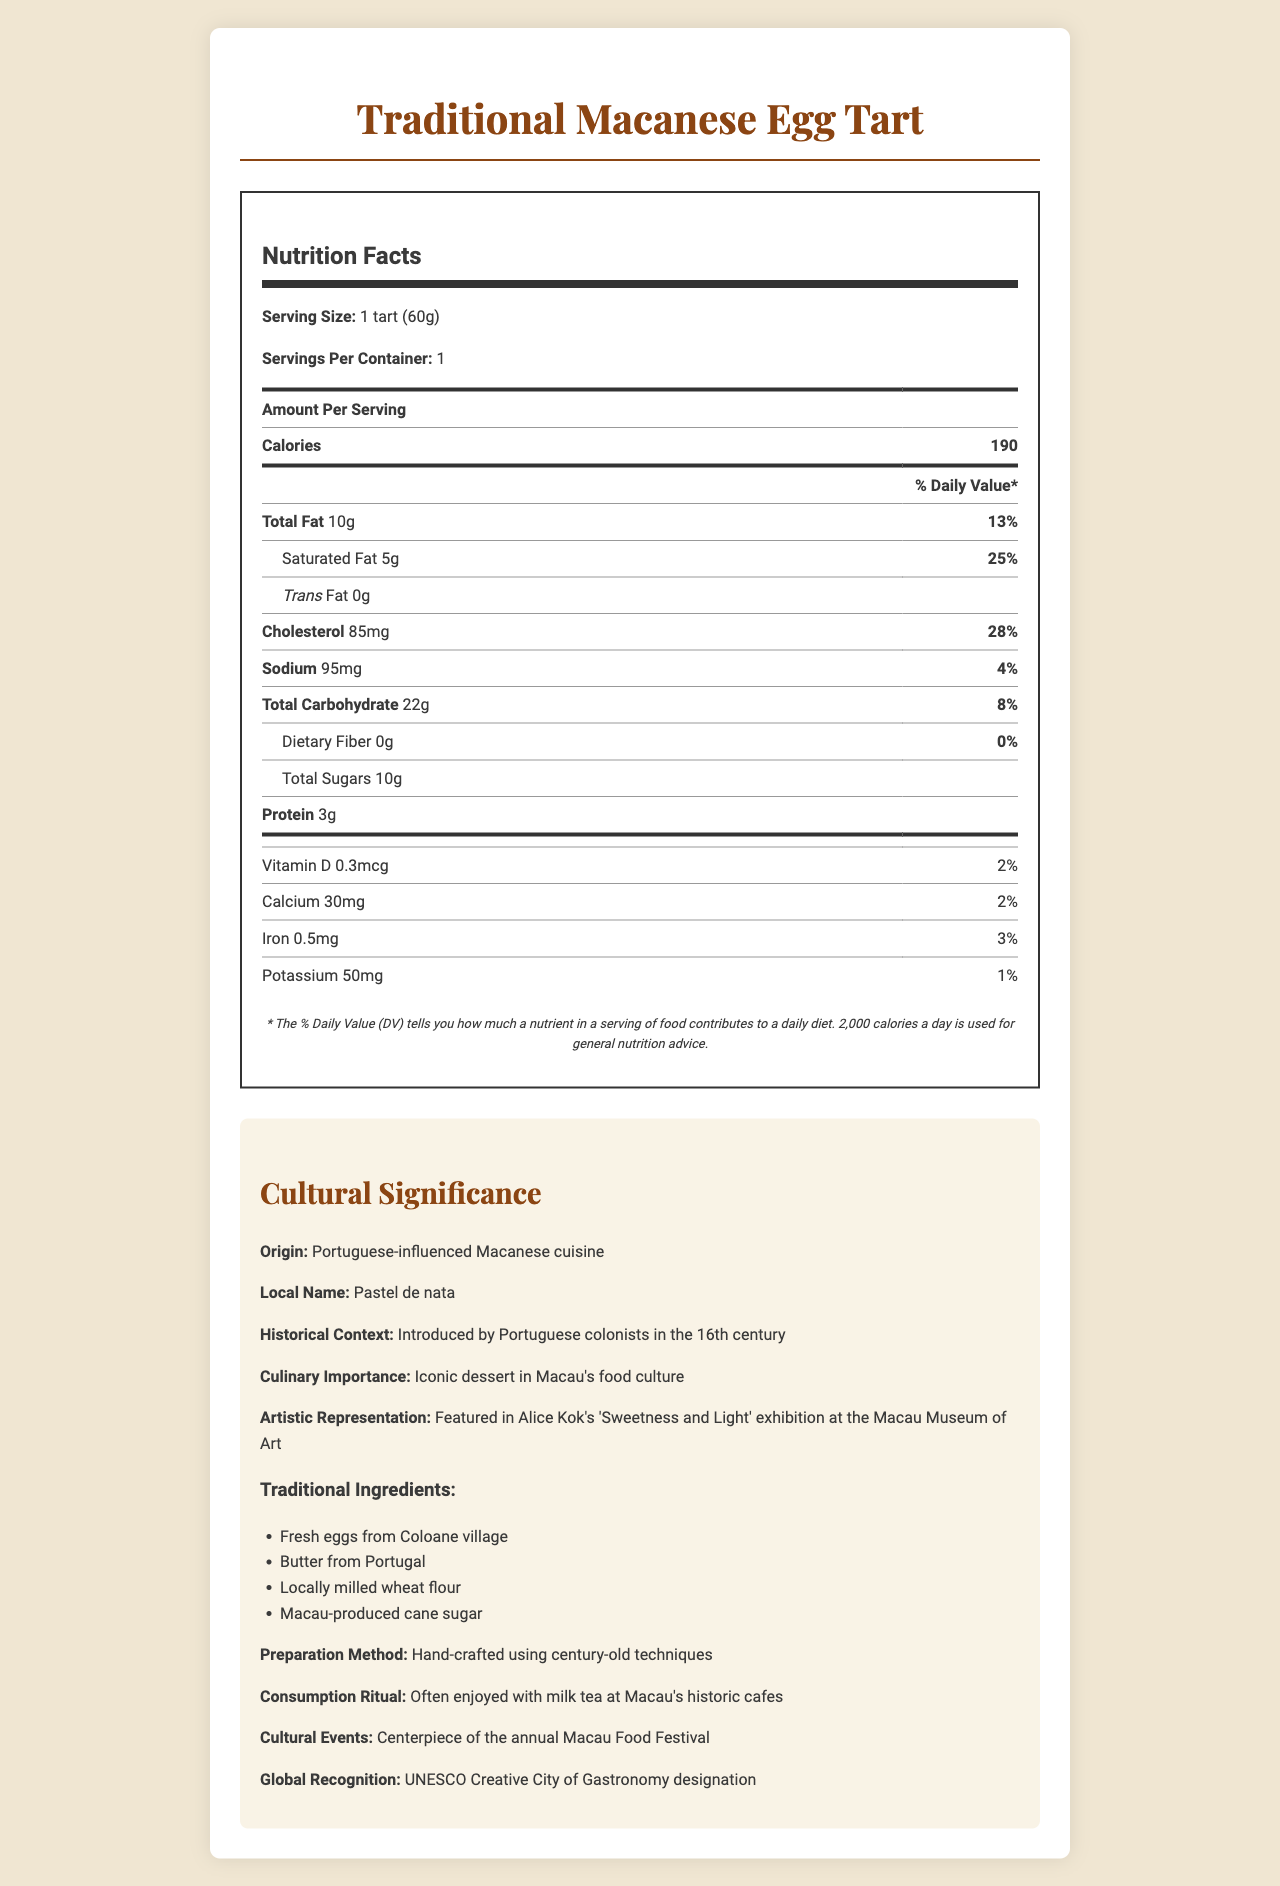how many calories are in a traditional Macanese egg tart? The document lists the number of calories as 190 per serving.
Answer: 190 what is the serving size for the traditional Macanese egg tart? The serving size is explicitly stated as "1 tart (60g)" on the label.
Answer: 1 tart (60g) how much saturated fat does one serving contain? The label indicates that each serving contains 5g of saturated fat.
Answer: 5g what is the daily value percentage of cholesterol in one traditional Macanese egg tart? The nutrition label specifies that the cholesterol content is 85mg, which is 28% of the daily value.
Answer: 28% which ingredient is traditionally sourced from Coloane village? Under the cultural significance section, it lists fresh eggs from Coloane village as one of the traditional ingredients.
Answer: Fresh eggs what is the origin of the traditional Macanese egg tart? The document mentions that the egg tart is part of Portuguese-influenced Macanese cuisine.
Answer: Portuguese-influenced Macanese cuisine how is the traditional Macanese egg tart commonly consumed? The cultural significance section states that egg tarts are often enjoyed with milk tea at historic cafes.
Answer: Often enjoyed with milk tea at Macau's historic cafes which event features the traditional Macanese egg tart as a centerpiece? A. Macau Arts Festival B. Macau Food Festival C. Macau Lantern Festival The cultural significance section notes that the egg tart is a centerpiece of the annual Macau Food Festival.
Answer: B what is the local name for the traditional Macanese egg tart? The document provides the local name as "Pastel de nata."
Answer: Pastel de nata how is the preparation method of the traditional Macanese egg tart described? The cultural significance section describes the preparation method as hand-crafted using century-old techniques.
Answer: Hand-crafted using century-old techniques does the traditional Macanese egg tart contain dietary fiber? The nutrition label shows that the dietary fiber content is 0g.
Answer: No has the traditional Macanese egg tart achieved any global recognition? The cultural significance section mentions that Macau has received the UNESCO Creative City of Gastronomy designation.
Answer: Yes how much protein does one traditional Macanese egg tart contain? The document lists the protein content as 3g per serving.
Answer: 3g based on the document, summarize the cultural significance of the traditional Macanese egg tart. This summary encapsulates the egg tart's origin, traditional methods and ingredients, cultural rituals, artistic representation, and global significance based on the document.
Answer: The traditional Macanese egg tart, known locally as Pastel de nata, is a Portuguese-influenced dessert that plays an iconic role in Macau's culinary heritage. Introduced by Portuguese colonists in the 16th century, it is hand-crafted using century-old techniques and traditional ingredients such as fresh eggs from Coloane village and butter from Portugal. It is often enjoyed with milk tea at historic cafes and is a centerpiece at the annual Macau Food Festival. The egg tart has even been featured in Alice Kok's artwork and contributed to Macau's recognition as a UNESCO Creative City of Gastronomy. how many traditional Macanese egg tarts are consumed daily in Macau? The document does not provide any information on the daily consumption quantity of egg tarts in Macau.
Answer: Cannot be determined 